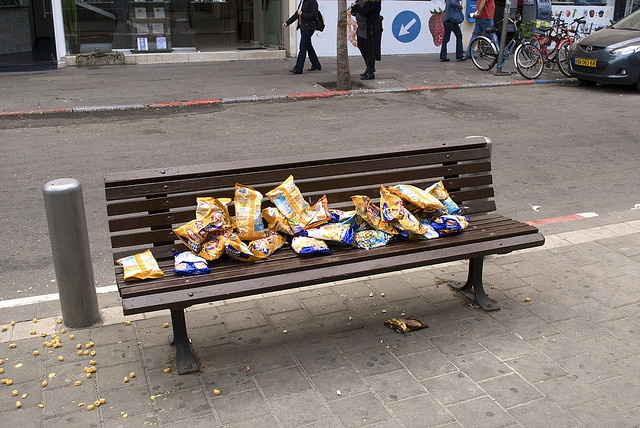Describe the objects in this image and their specific colors. I can see bench in black, darkgray, gray, and white tones, car in black, gray, darkgray, and lavender tones, bicycle in black, gray, darkgray, and white tones, people in black, gray, and lavender tones, and people in black, gray, darkgray, and lightgray tones in this image. 